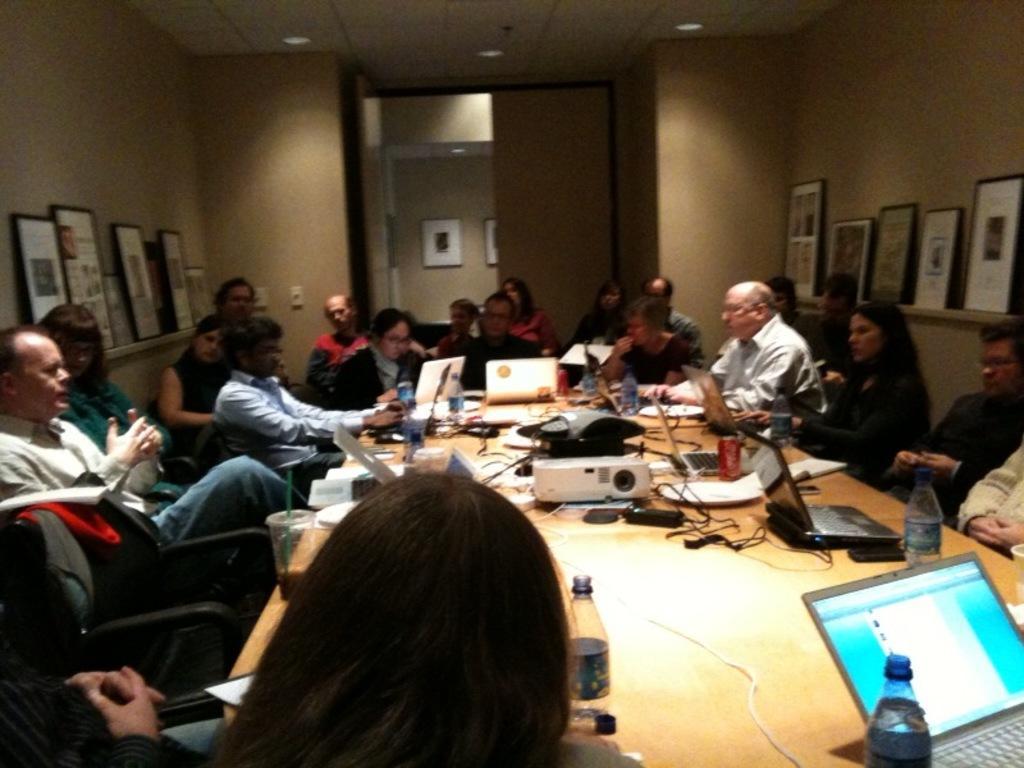In one or two sentences, can you explain what this image depicts? We can see frames over a wall. This is a door. We can see all the persons sitting on chairs in front of a table and on the table we can see projector device, bottle, laptop, tin ,wires. 